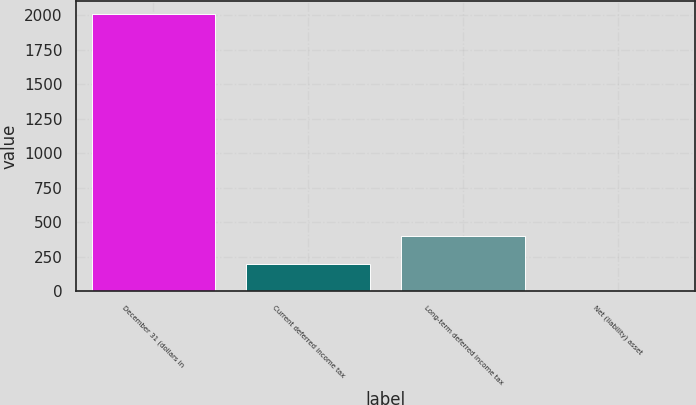Convert chart to OTSL. <chart><loc_0><loc_0><loc_500><loc_500><bar_chart><fcel>December 31 (dollars in<fcel>Current deferred income tax<fcel>Long-term deferred income tax<fcel>Net (liability) asset<nl><fcel>2007<fcel>201.15<fcel>401.8<fcel>0.5<nl></chart> 